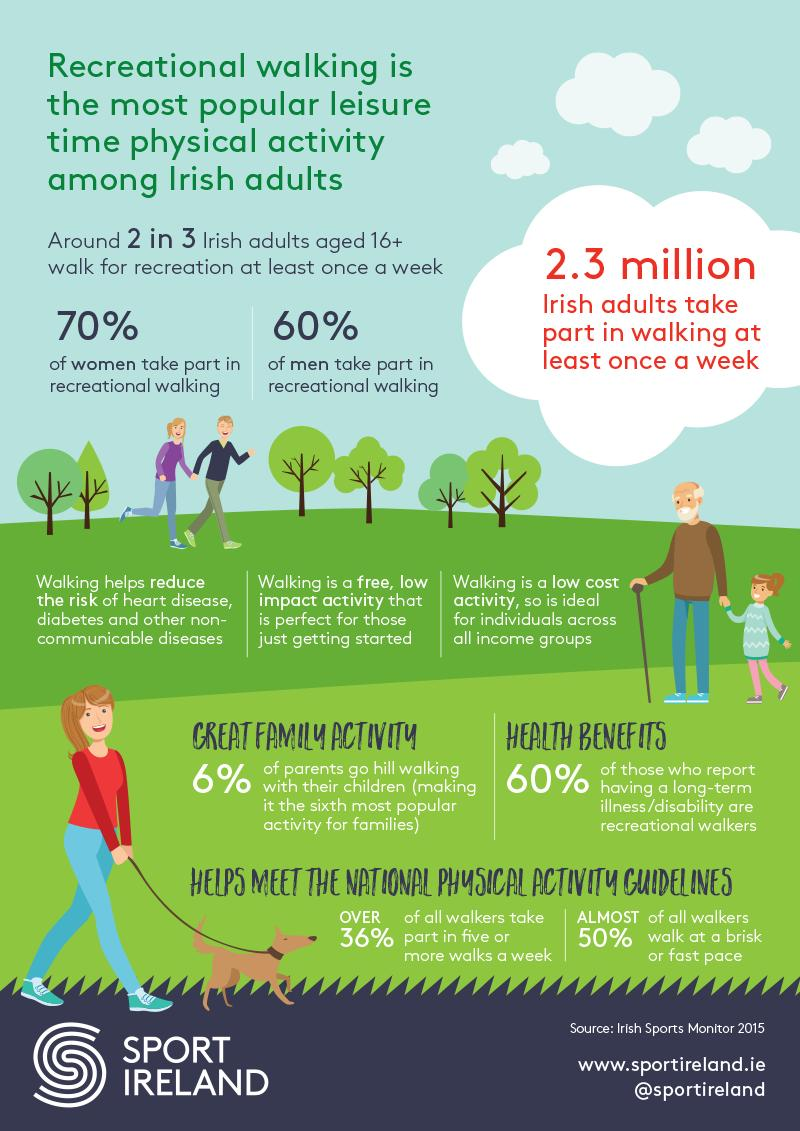Draw attention to some important aspects in this diagram. According to data, the percentage of women and men who participate in recreational walking is approximately 10%. 